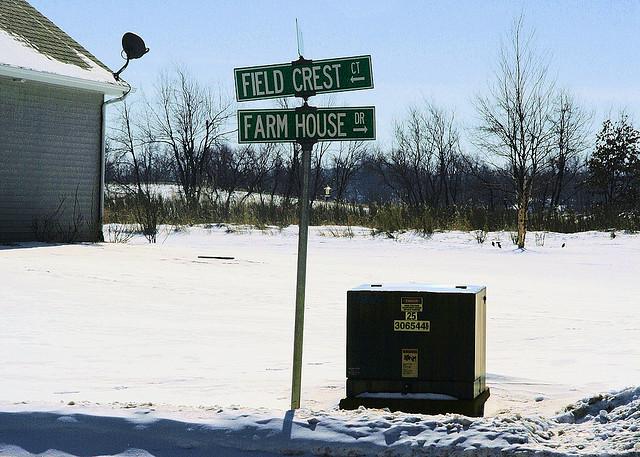What color is the sky?
Be succinct. Blue. What color is the ground?
Answer briefly. White. What is the name of the street heading to the right?
Concise answer only. Farmhouse. 